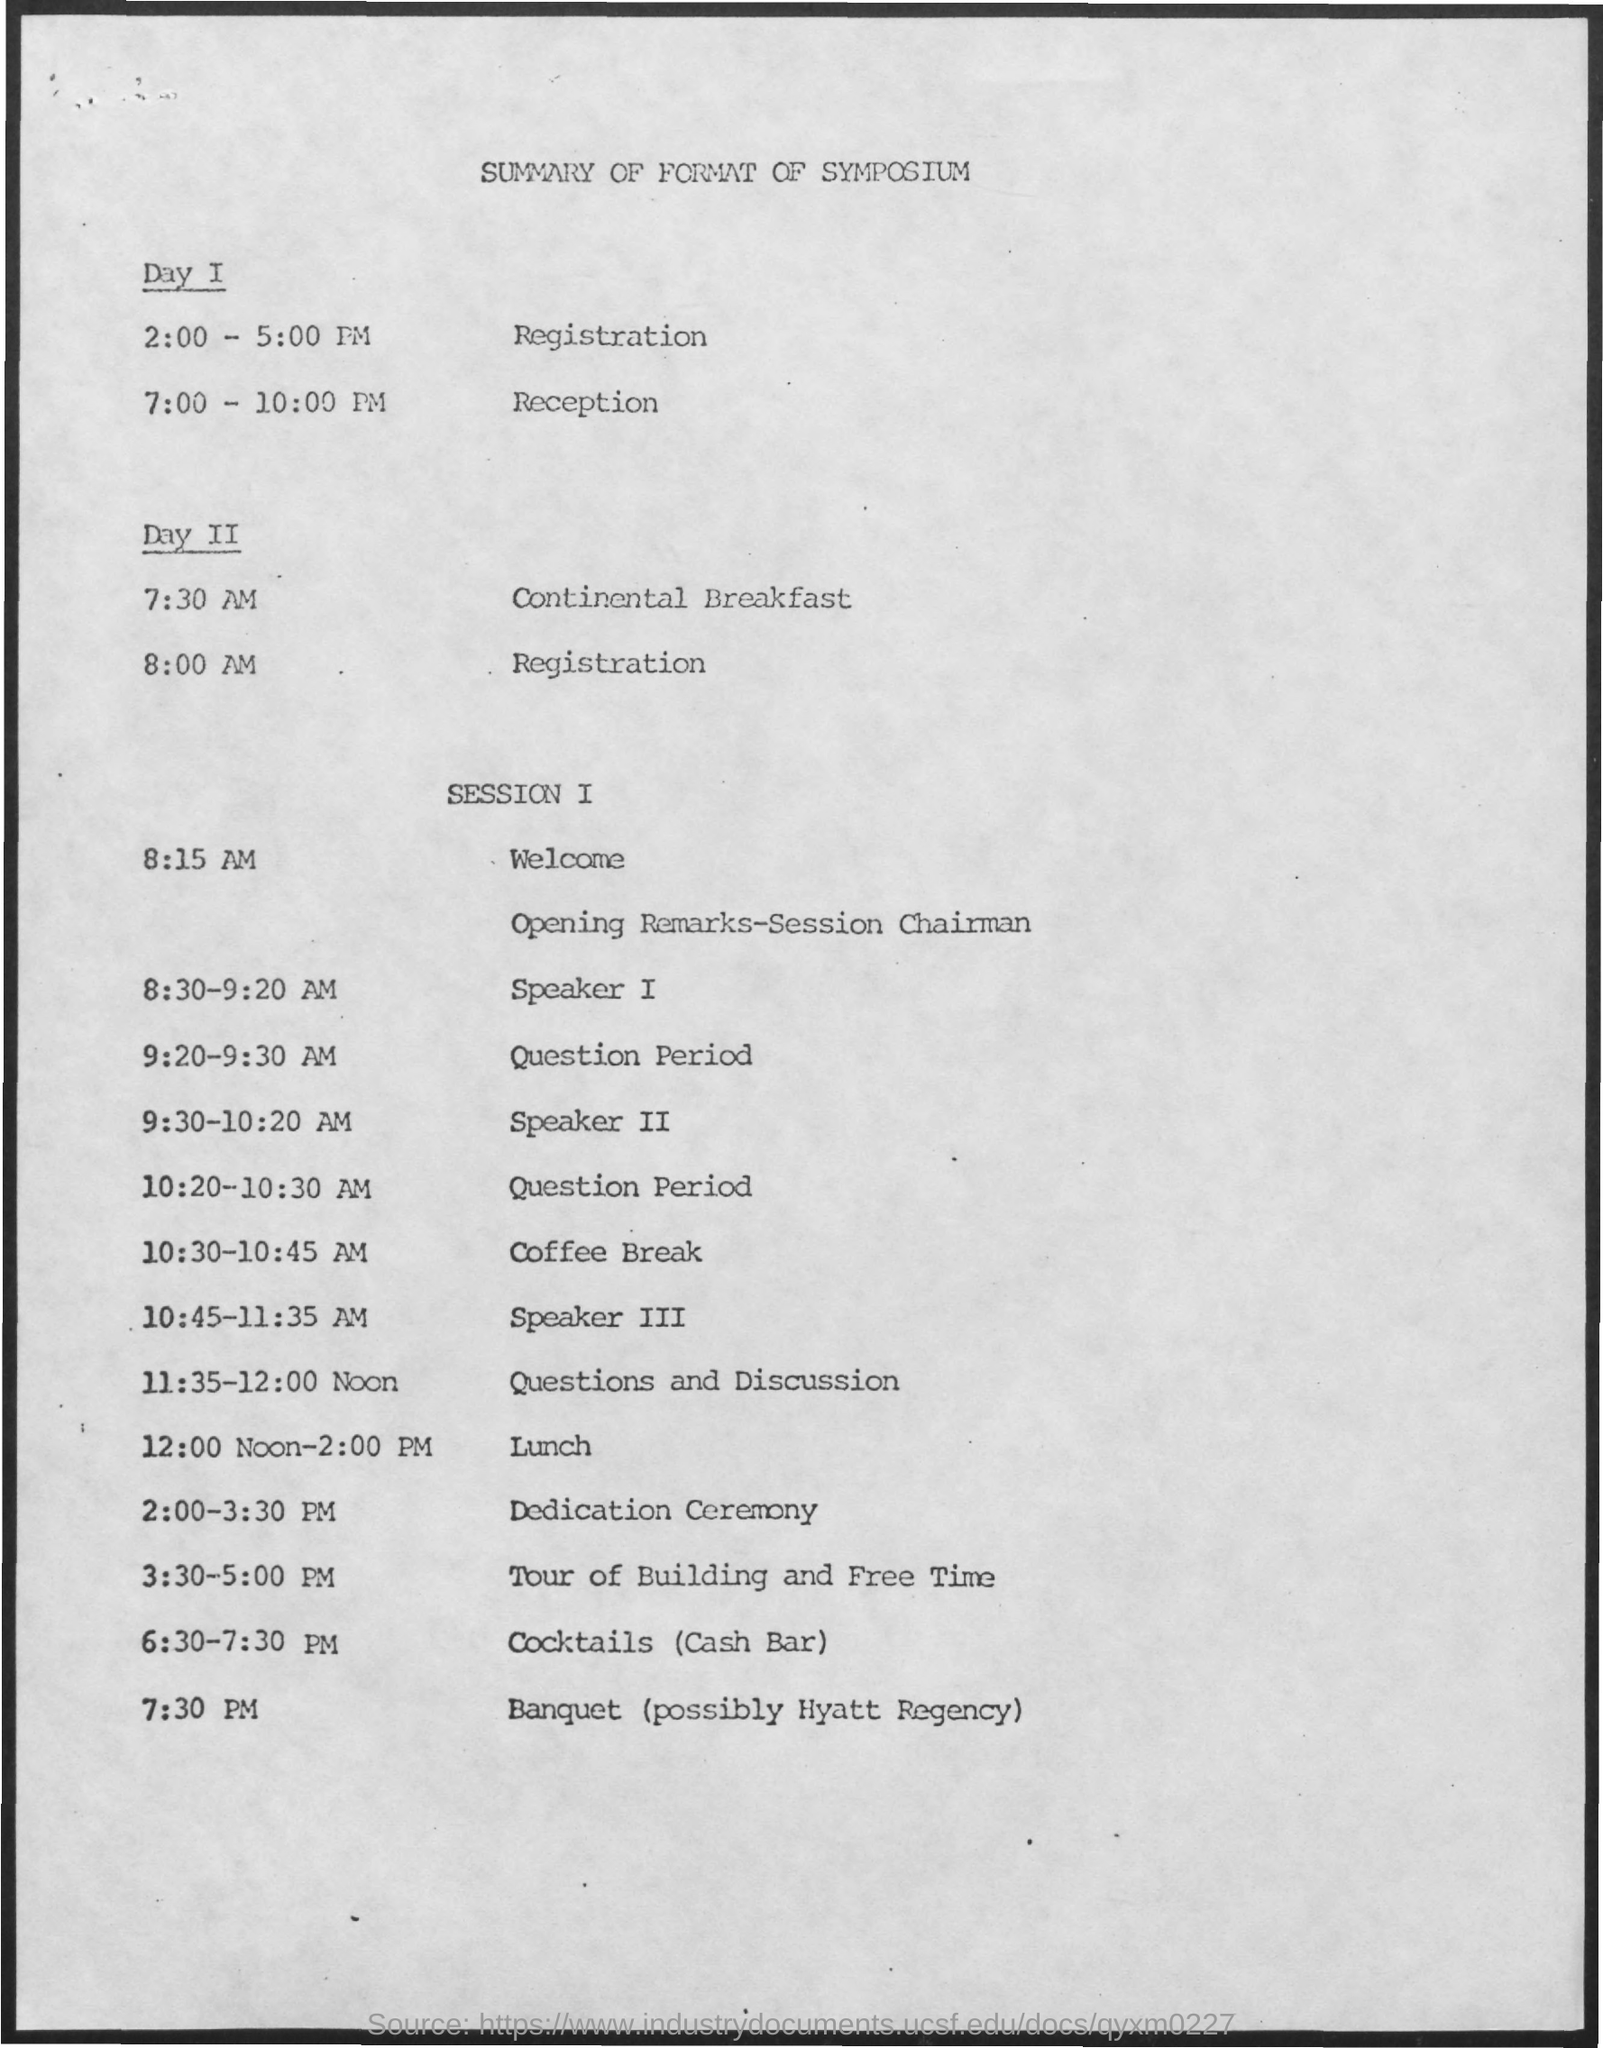Identify some key points in this picture. The schedule at 7:00-10:00 pm on day 1 at the reception desk is as follows: At 7:30 am on day 2, the schedule will be as follows: continental breakfast will be served. The schedule at 2:00-5:00 pm on day 1 is registration. The schedule at 8:00 am on day 2 will be the registration process. At the time of 12:00 noon-2:00 pm in Session 1, the schedule is as follows: Lunch will be held. 